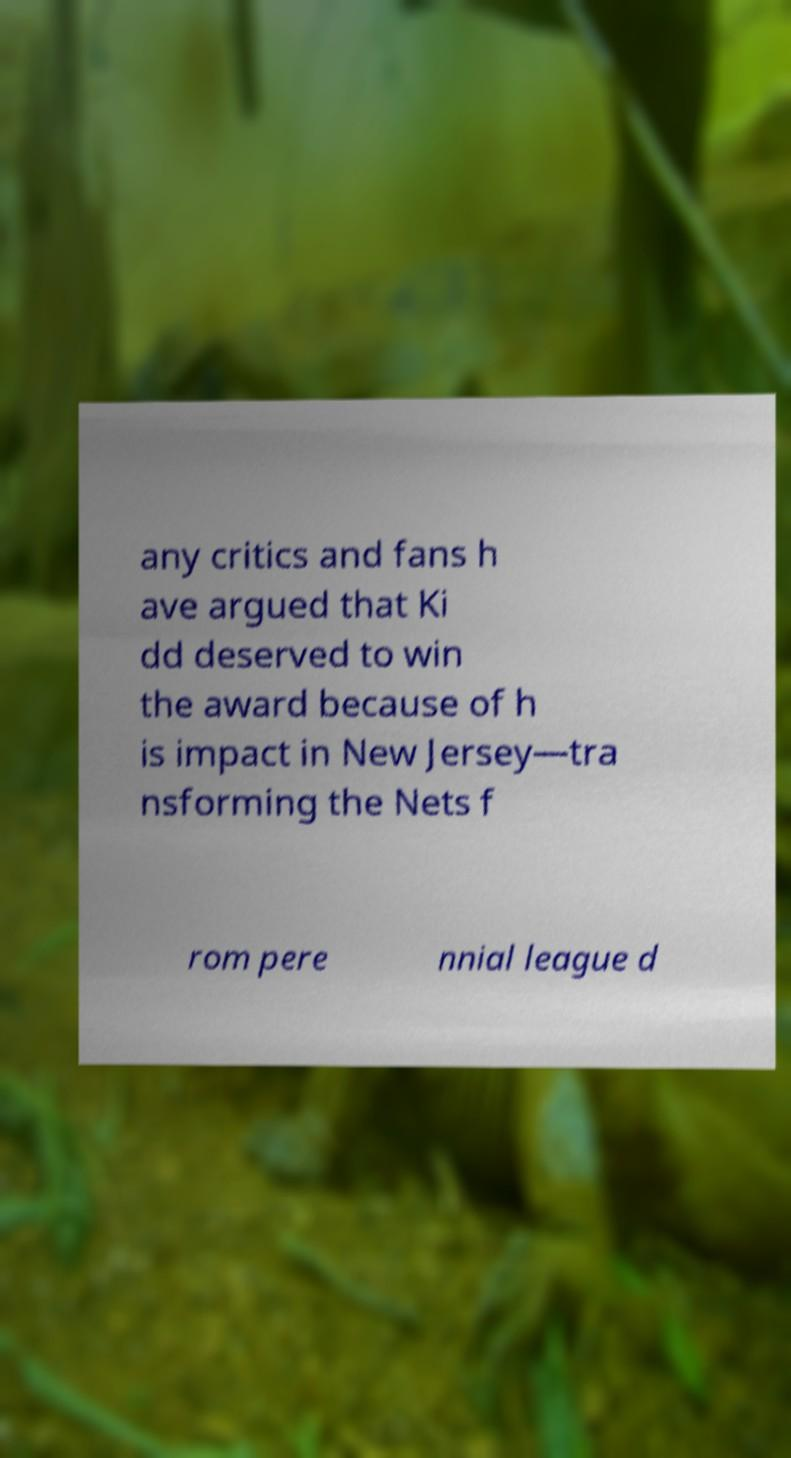Please read and relay the text visible in this image. What does it say? any critics and fans h ave argued that Ki dd deserved to win the award because of h is impact in New Jersey—tra nsforming the Nets f rom pere nnial league d 